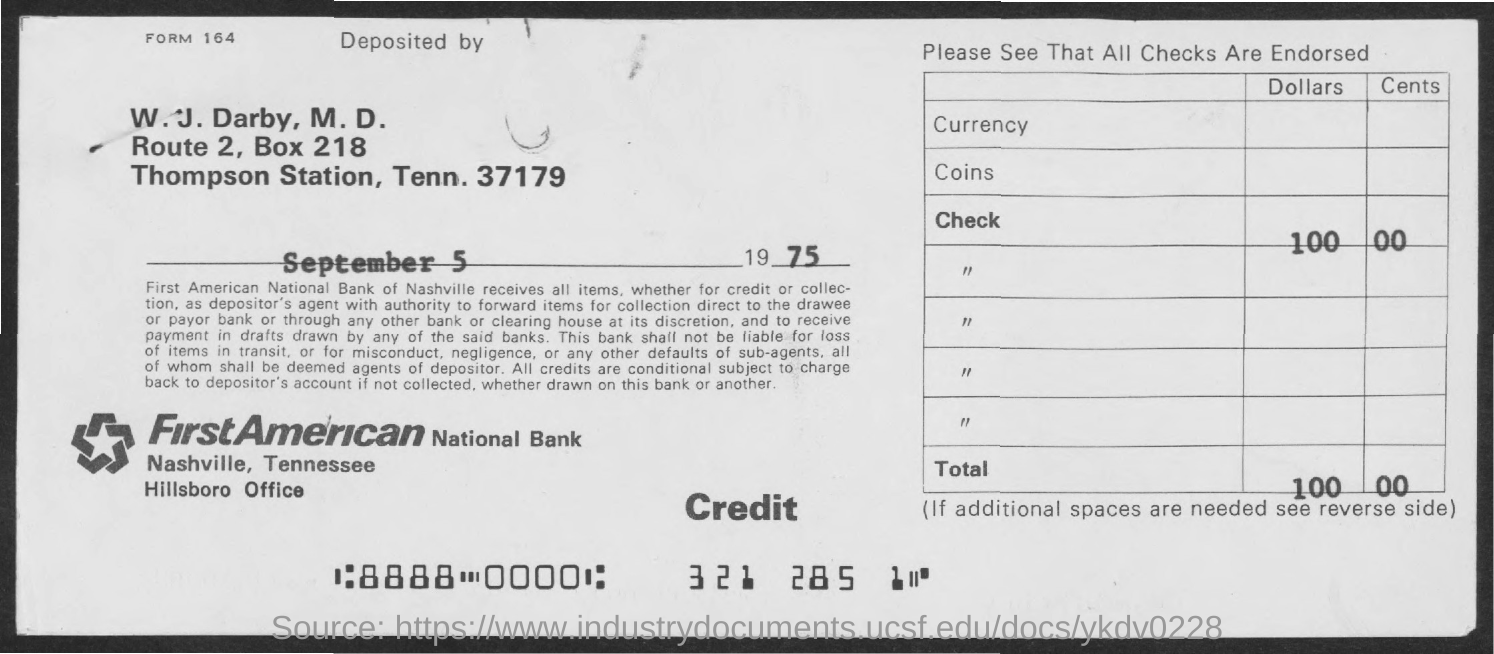Outline some significant characteristics in this image. What is the form number provided in this context? The check in question was issued by FirstAmerican National Bank. 